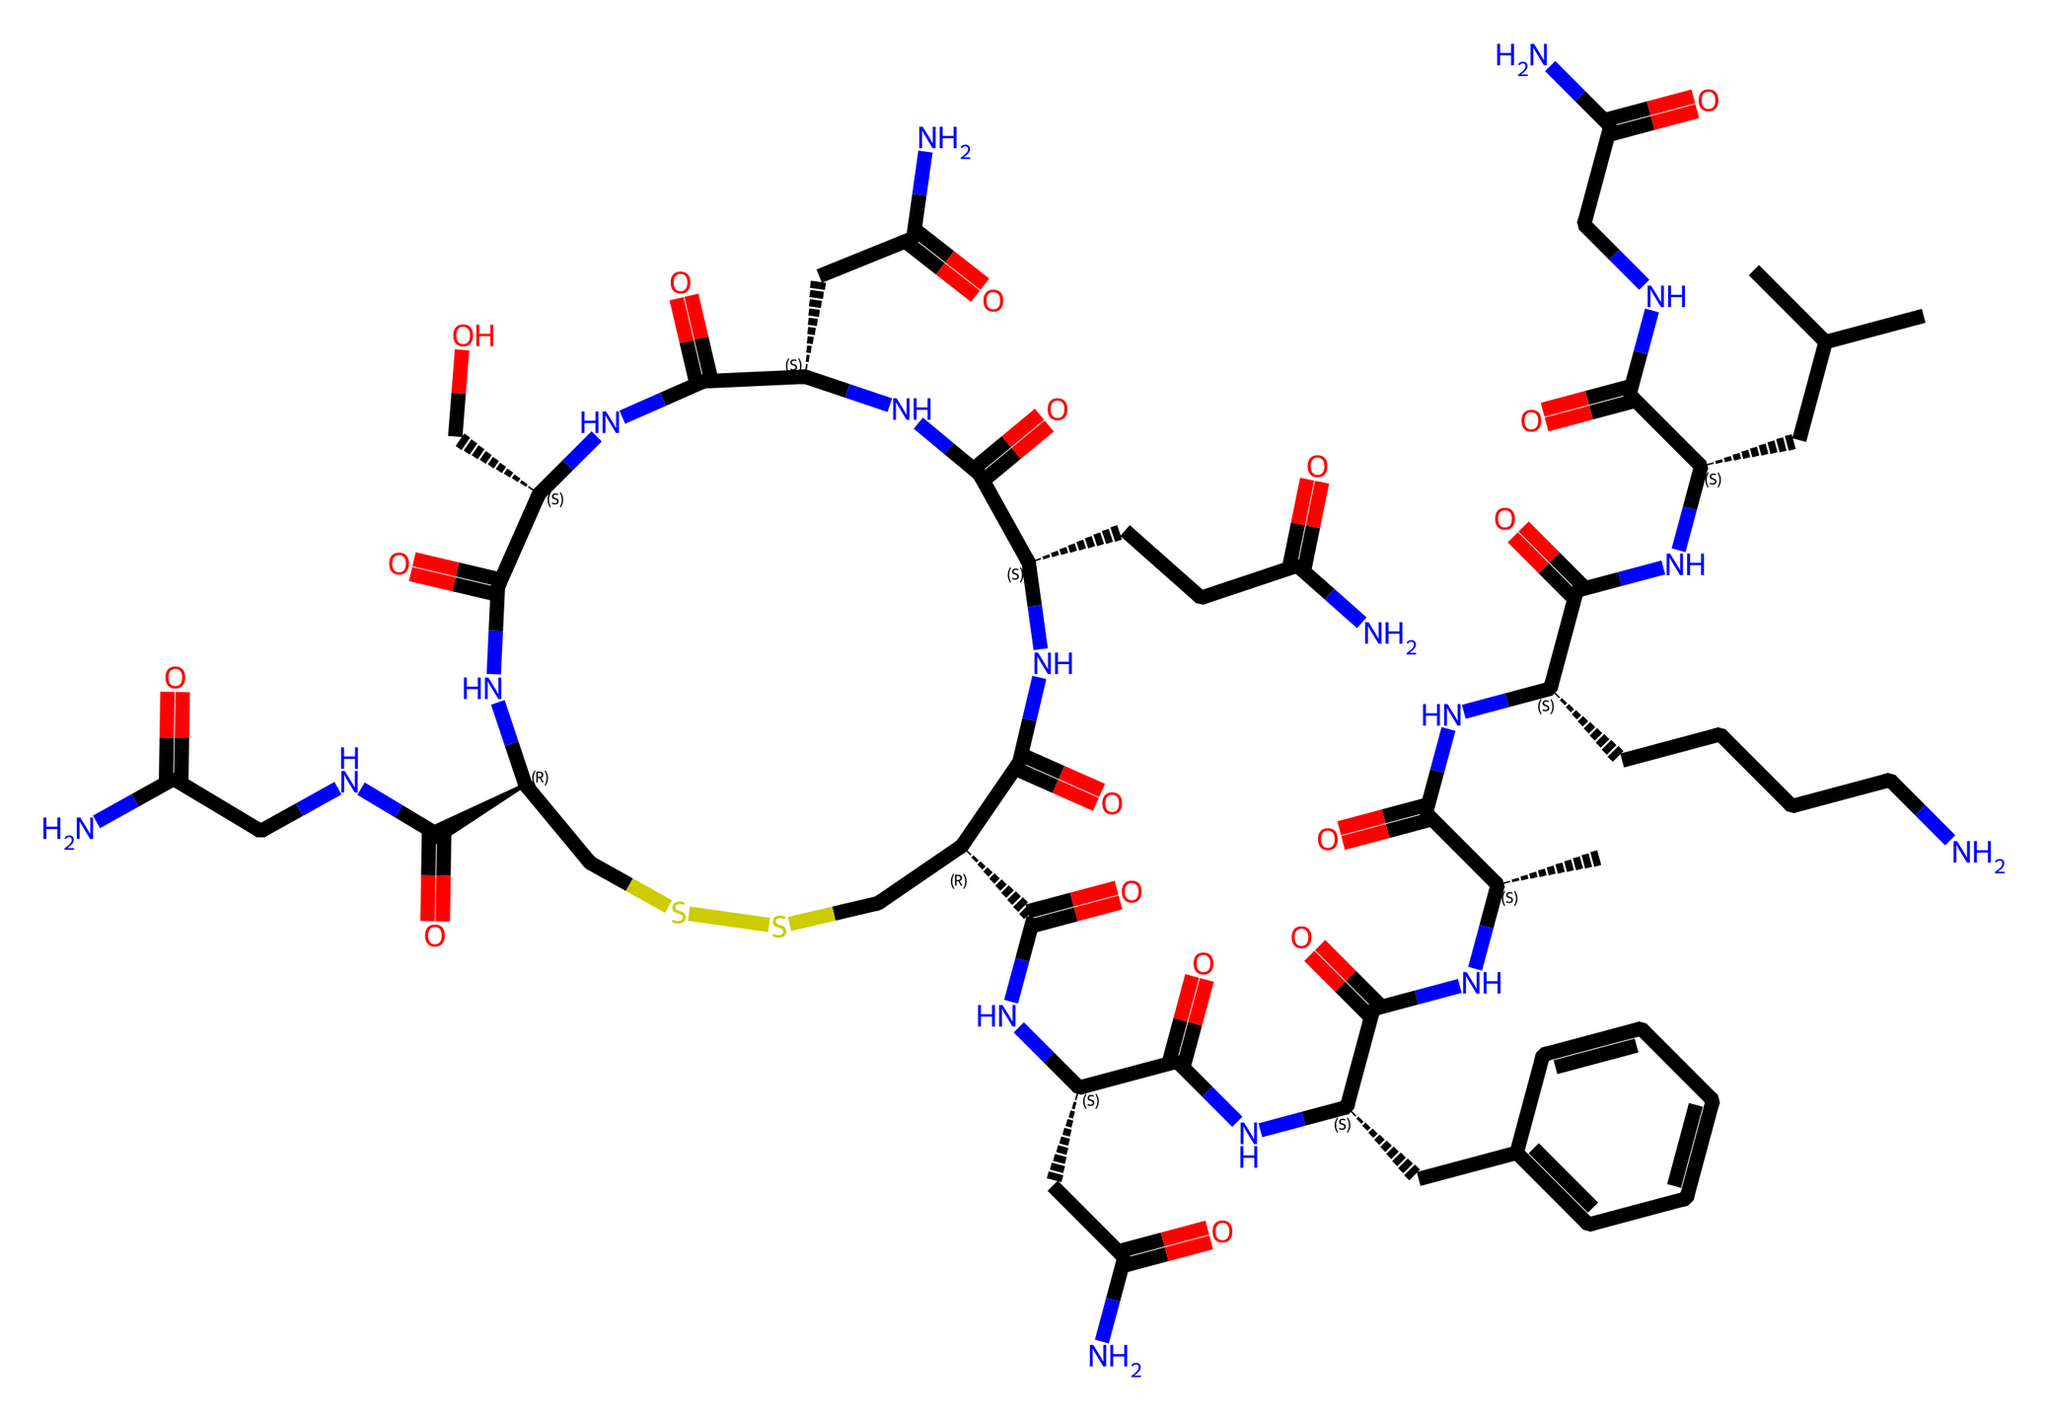What is the main function of oxytocin in social settings? Oxytocin plays a crucial role in promoting social bonds and nurturing behaviors, which are essential in professional interactions and teamwork.
Answer: social bonding How many nitrogen atoms are present in the chemical structure of oxytocin? By analyzing the SMILES representation, we count a total of seven nitrogen (N) atoms in the chemical structure.
Answer: seven Which type of chemical is oxytocin categorized as? Oxytocin is categorized as a peptide hormone, as it consists of amino acids linked by peptide bonds.
Answer: peptide hormone Does the oxytocin structure contain any sulfur atoms? Yes, the structure contains two sulfur (S) atoms, as indicated by the presence of the "S" in the chemical representation.
Answer: yes Which functional group is predominantly found in the oxytocin structure? The main functional group present in oxytocin is the amide group, which is recognizable by the -C(=O)N- pattern throughout the structure.
Answer: amide group What aspect of oxytocin is believed to influence workplace dynamics? The influence of oxytocin on emotions, trust, and cooperation significantly affects workplace social dynamics and collaboration.
Answer: trust 